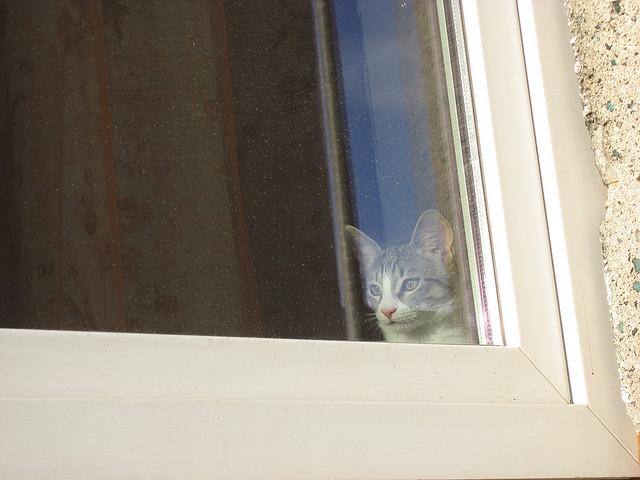Was the person taking this picture tall?
Write a very short answer. No. Is the window closed?
Quick response, please. Yes. Is this cat trying to get inside the window?
Write a very short answer. No. What is the cat looking out of?
Short answer required. Window. What is on the window sill?
Write a very short answer. Cat. Is the window broken?
Keep it brief. No. 